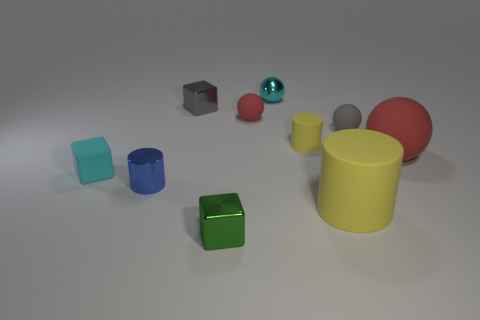What number of other objects are there of the same material as the tiny blue cylinder?
Your response must be concise. 3. Is the number of gray matte things that are in front of the big red rubber object less than the number of yellow shiny cylinders?
Offer a terse response. No. Is the shape of the tiny red thing the same as the big red rubber thing?
Ensure brevity in your answer.  Yes. What size is the red matte thing that is on the right side of the shiny thing that is behind the small shiny block that is behind the tiny blue metallic thing?
Your answer should be very brief. Large. There is a small gray object that is the same shape as the small red object; what is it made of?
Offer a very short reply. Rubber. There is a gray thing that is to the left of the gray thing to the right of the cyan ball; how big is it?
Provide a short and direct response. Small. What color is the big matte cylinder?
Make the answer very short. Yellow. There is a cyan thing that is right of the small green metal object; how many balls are on the right side of it?
Ensure brevity in your answer.  2. There is a red ball that is behind the tiny yellow thing; is there a tiny gray rubber object to the right of it?
Keep it short and to the point. Yes. Are there any objects left of the green thing?
Give a very brief answer. Yes. 